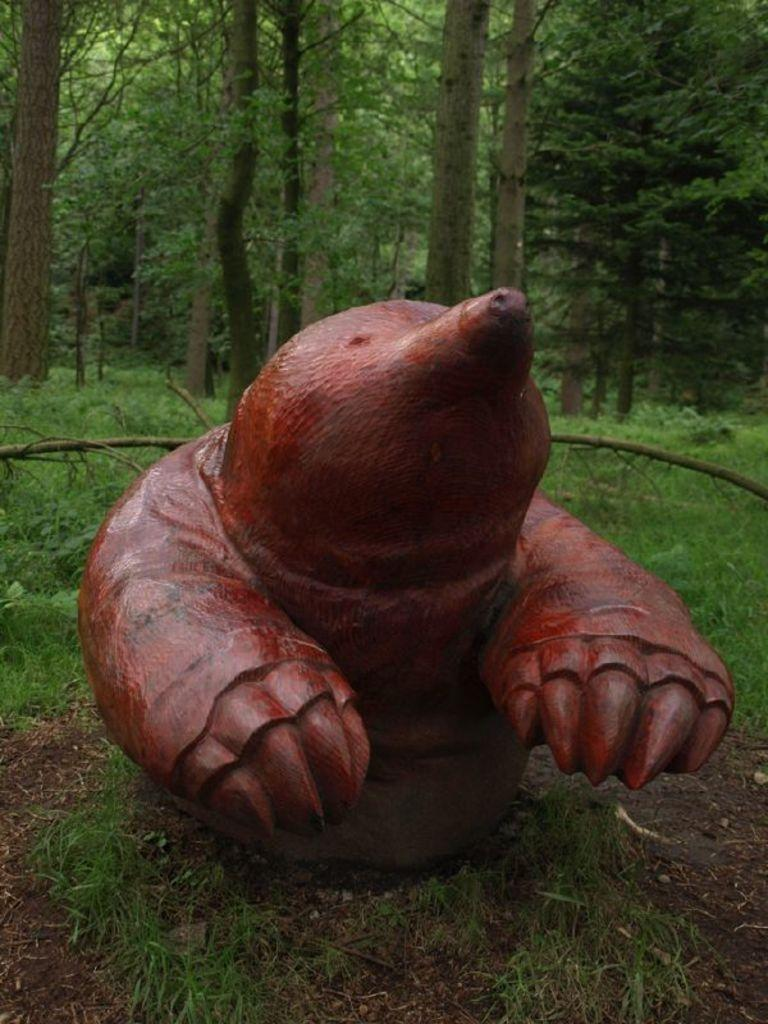What type of natural environment is depicted in the image? There is a forest in the image. What specific features can be found in the forest? There are trees in the image. What stands out as an unusual object in the forest? There is a red color sculpture of an animal in the middle of the image. What type of coal can be seen in the image? There is no coal present in the image. What type of crime is being committed in the image? There is no crime depicted in the image. 